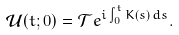Convert formula to latex. <formula><loc_0><loc_0><loc_500><loc_500>\mathcal { U } ( t ; 0 ) = \mathcal { T } e ^ { i \int ^ { t } _ { 0 } K ( s ) \, d s } .</formula> 